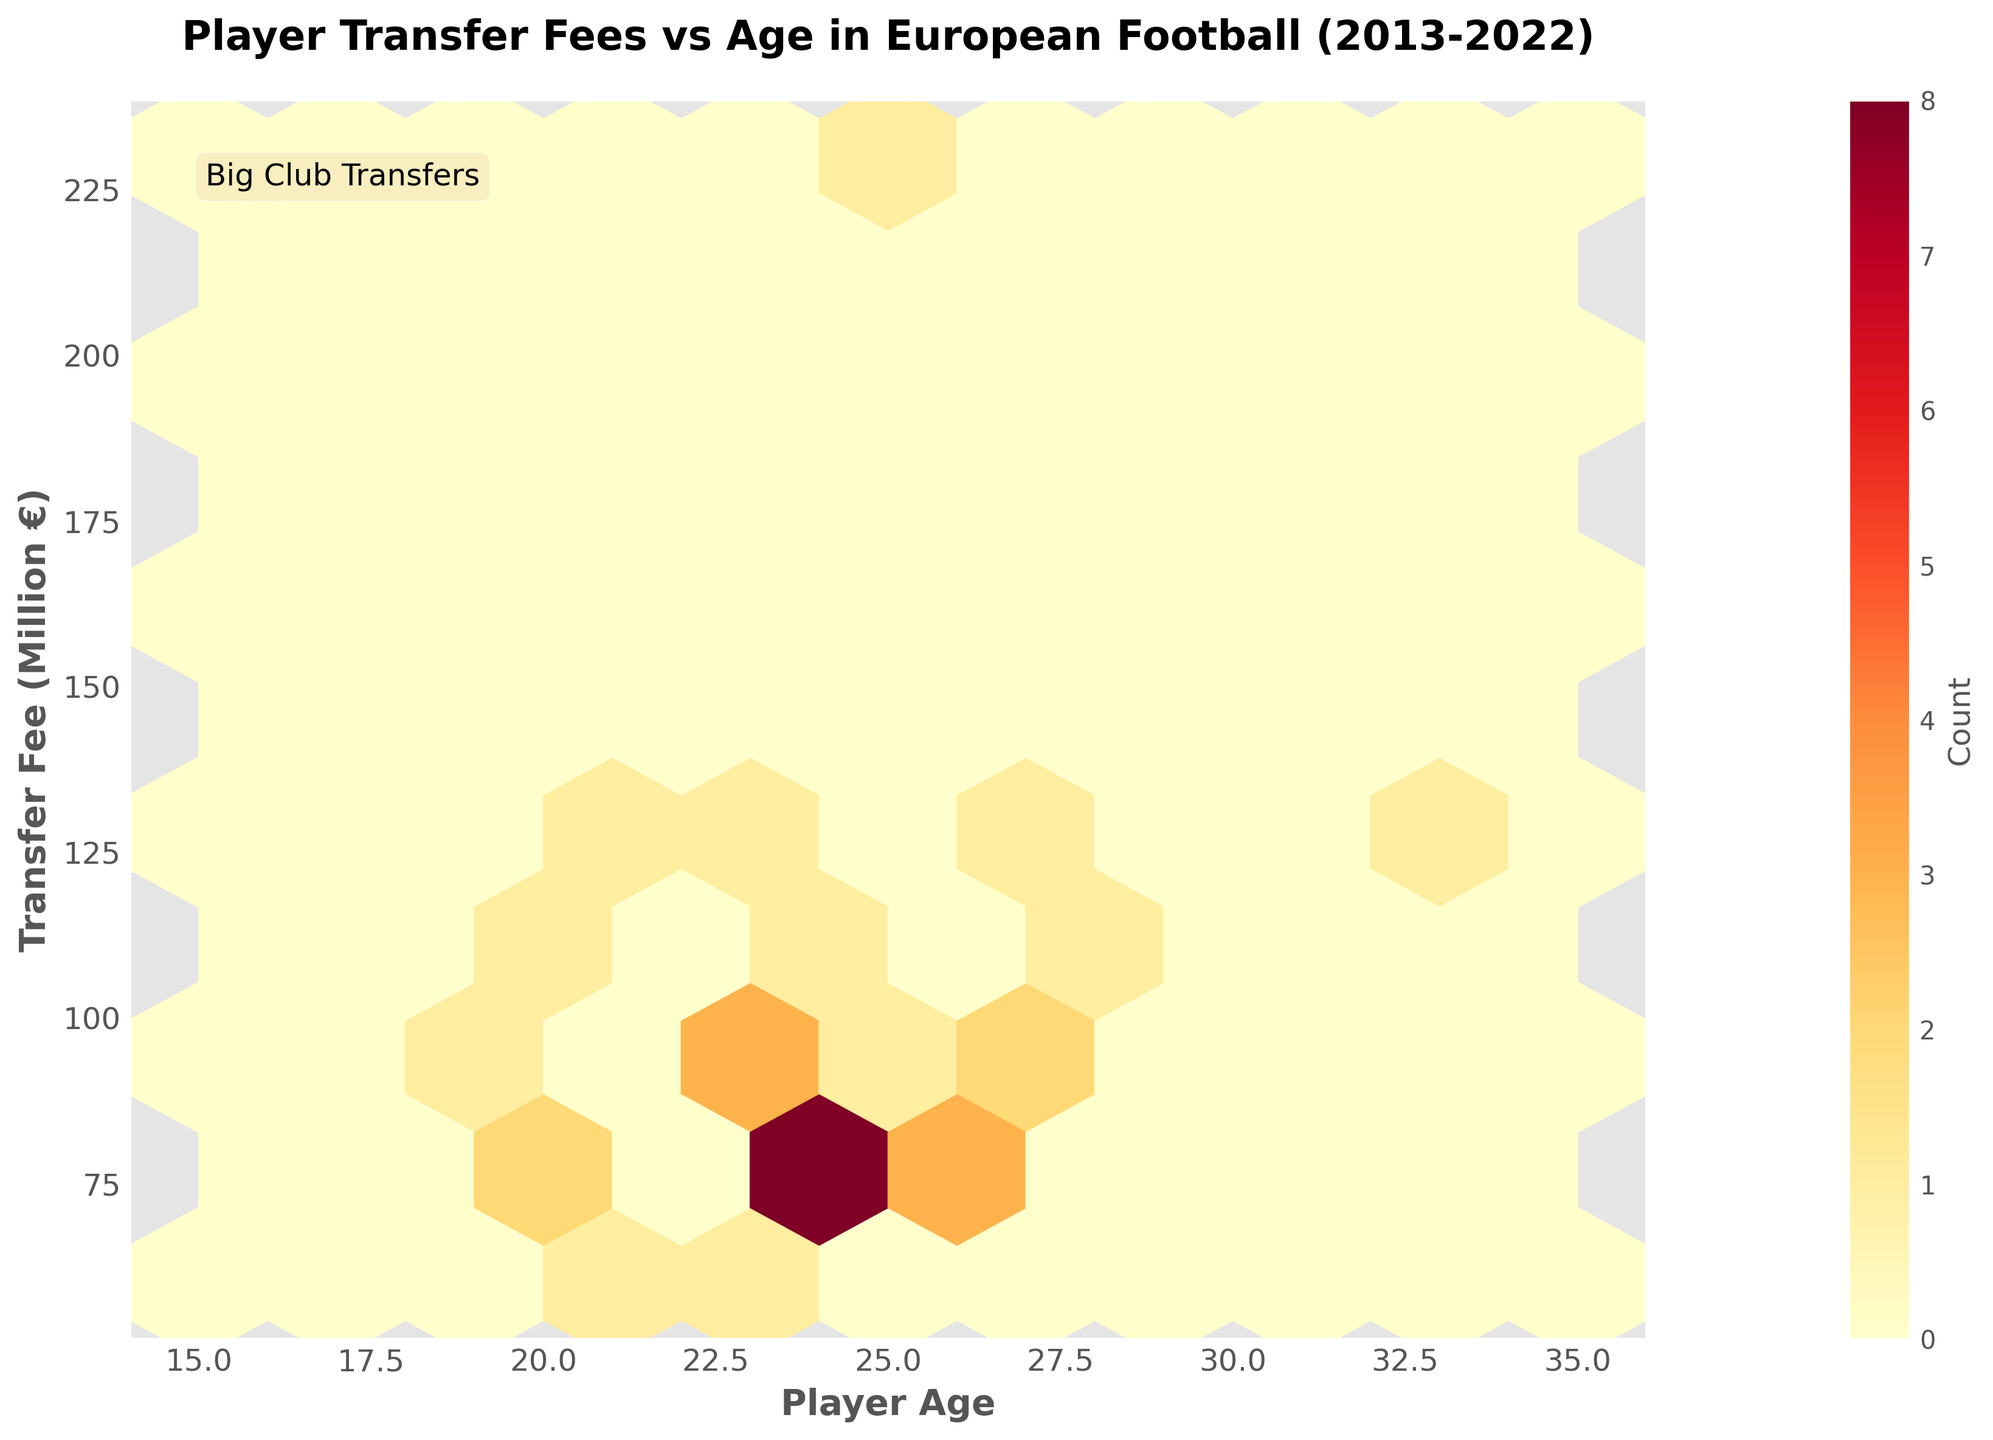What is the title of the figure? The title of the figure is displayed at the top and reads "Player Transfer Fees vs Age in European Football (2013-2022)".
Answer: Player Transfer Fees vs Age in European Football (2013-2022) What are the x and y axes labeled? The x-axis label is "Player Age" and the y-axis label is "Transfer Fee (Million €)". These are positioned below the x-axis and to the left of the y-axis, respectively.
Answer: Player Age, Transfer Fee (Million €) What is the color gradient used in the Hexbin Plot? The color gradient is from yellow to red, indicating increasing density of data points from low to high. This can be seen in the varying color intensity in the plot.
Answer: Yellow to Red Where do most player transfer fees tend to cluster in terms of age and fee? The densest clusters are in the range of player ages 23-25 and transfer fees between 80 and 120 million €. This is indicated by the darker (red) and more populated hexagons in that region.
Answer: Ages 23-25, Fees 80-120 million € What is the highest transfer fee recorded in the plot? The highest transfer fee shown in the plot is 222 million €, visible at the top edge of the y-axis.
Answer: 222 million € How are younger players (ages 18-20) typically priced in the transfer market? Younger players (ages 18-20) generally have transfer fees within the range of 70-90 million €, as indicated by the concentration and density of hexagons in this age and fee area.
Answer: 70-90 million € What age and fee range has the least number of transfers? The least number of transfers tend to occur for players aged 35 and above, and transfer fees below 70 million €, as there are few or no hexagons colored in these ranges.
Answer: Ages 35+, Fees < 70 million € How does the color of the plot change as the density of player transfers increases? As the density increases, the color of the hexagons transitions from yellow to deeper shades of red, indicating higher density regions.
Answer: From yellow to red What is the plot's color bar label? The color bar label is "Count", showing the concentration of transfer counts represented by the color intensity.
Answer: Count Which age group shows the highest variety of transfer fees? Players aged 23-25 display the highest variety of transfer fees, ranging from 60 million € to above 120 million €, as evidenced by the wider spread of varying hexagon colors in this age group.
Answer: Ages 23-25 